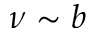Convert formula to latex. <formula><loc_0><loc_0><loc_500><loc_500>\nu \sim b</formula> 